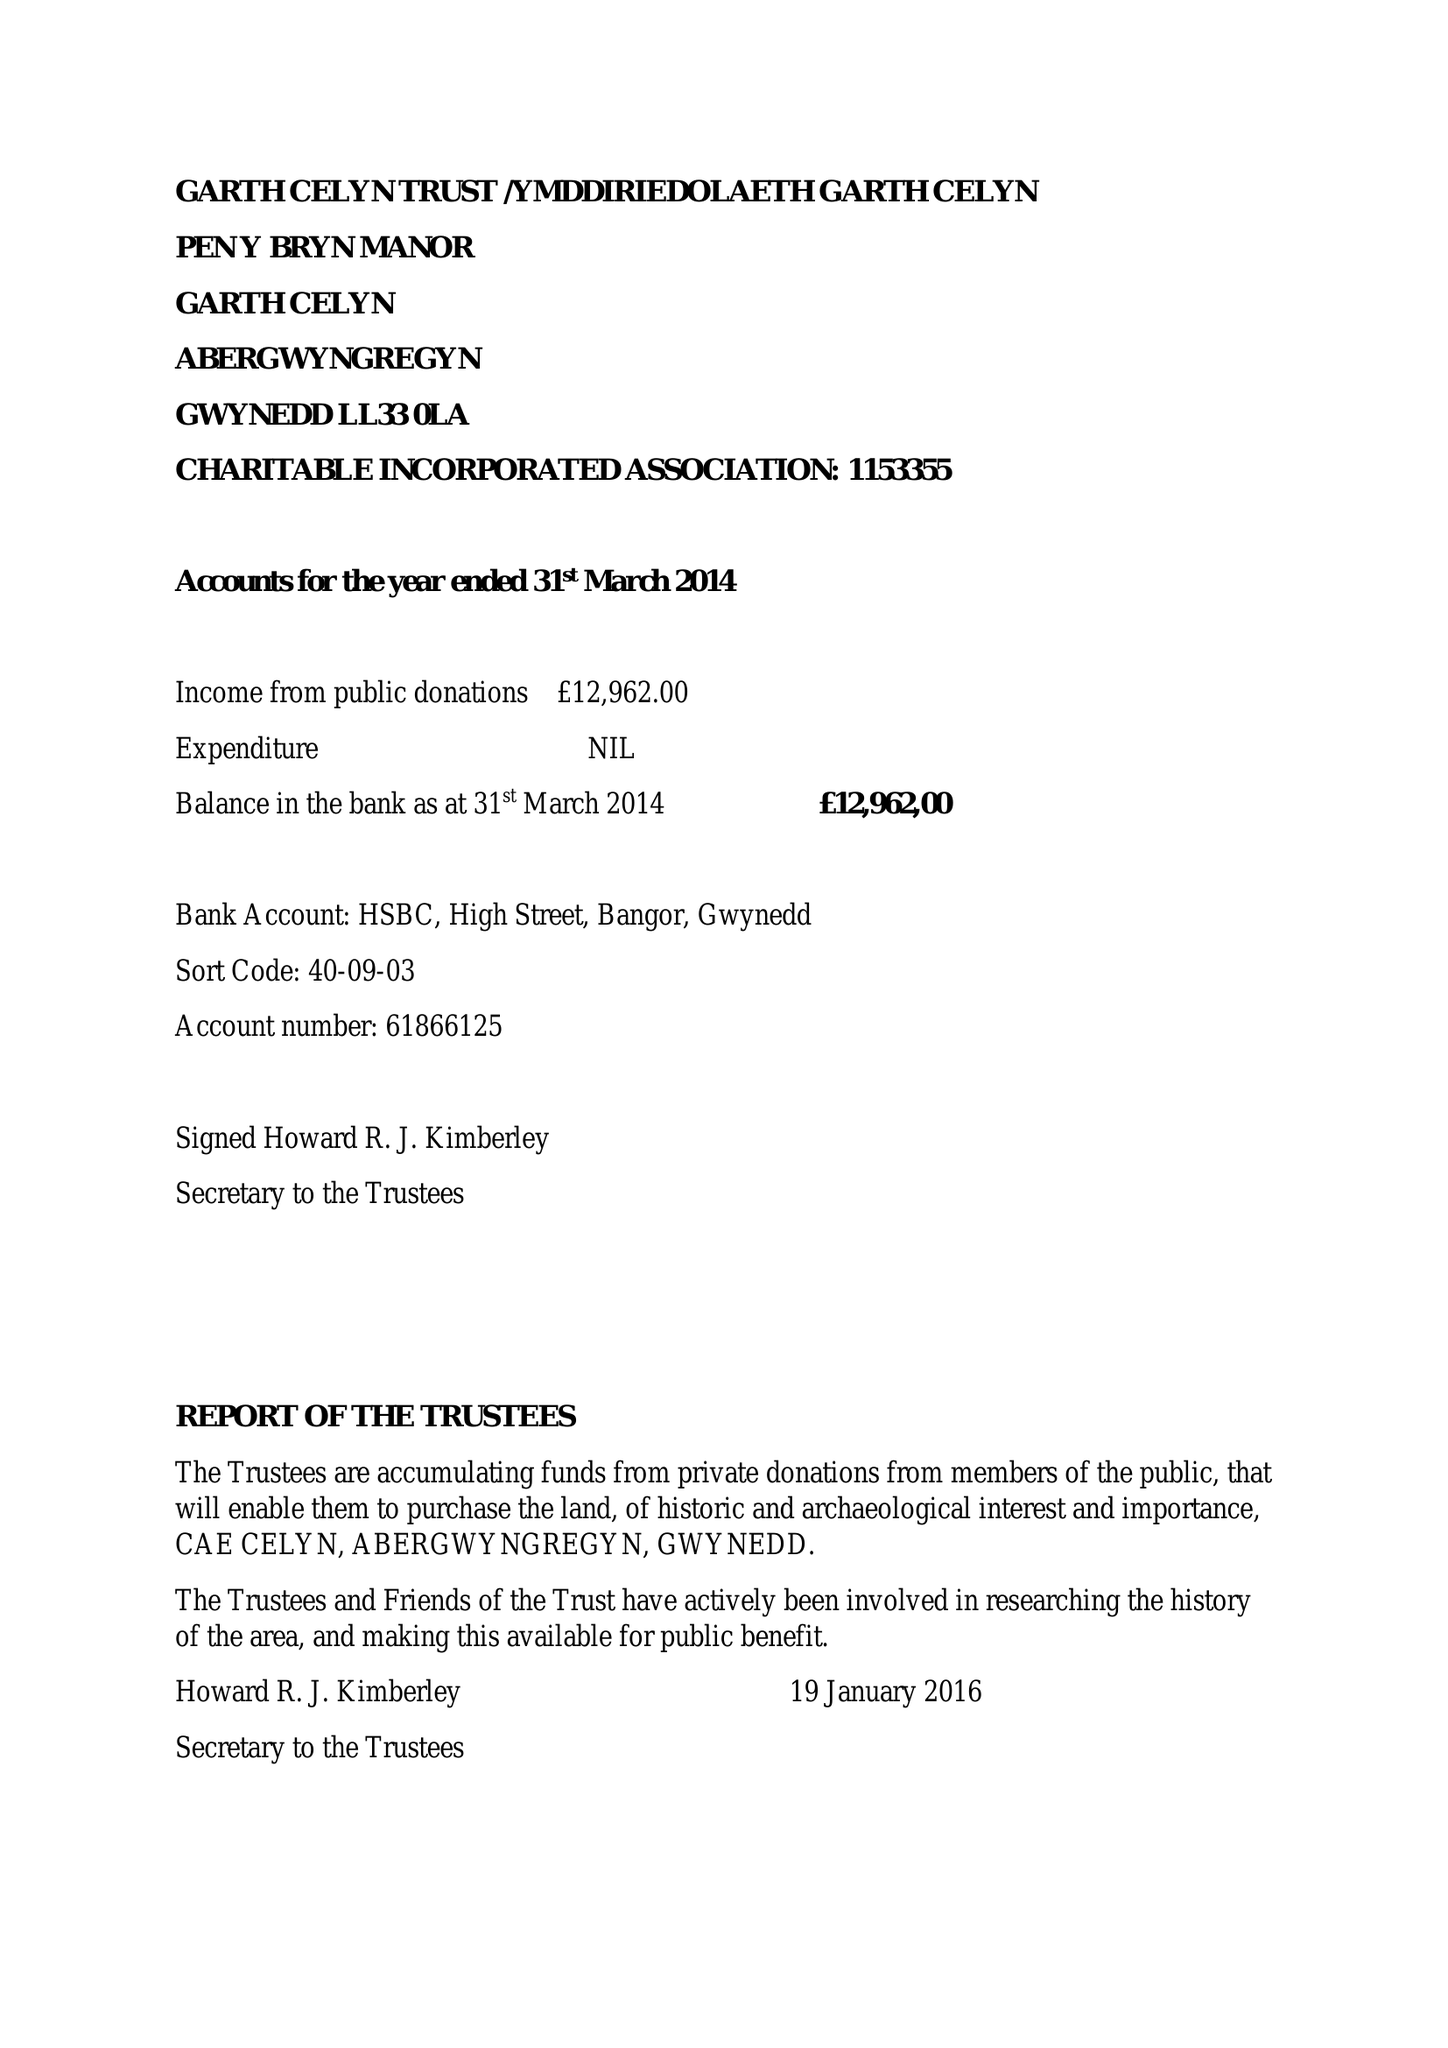What is the value for the address__postcode?
Answer the question using a single word or phrase. LL33 0LA 